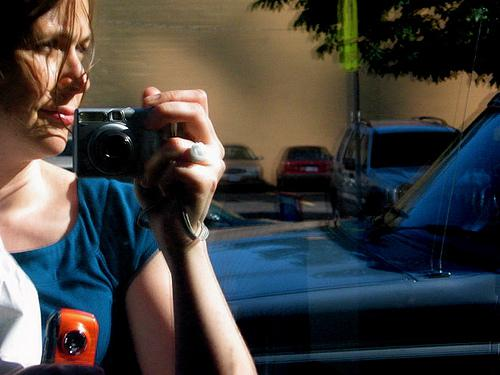Question: how is the woman standing?
Choices:
A. Still.
B. On one foot.
C. Leaning on the wall.
D. On tip toes.
Answer with the letter. Answer: A Question: why is she holding the camera?
Choices:
A. To take a picture.
B. To load it.
C. To fix it.
D. To unwrap it.
Answer with the letter. Answer: A Question: what is she doing?
Choices:
A. Walking.
B. Sitting on a bench.
C. On phone.
D. Taking a picture.
Answer with the letter. Answer: D Question: where is this taken?
Choices:
A. In a park.
B. At the beach.
C. Outside a building.
D. At the airport.
Answer with the letter. Answer: C Question: what color shirt is she wearing?
Choices:
A. Green.
B. Yellow.
C. Blue.
D. White.
Answer with the letter. Answer: C Question: when did this happen?
Choices:
A. During the day.
B. At night.
C. At Dusk.
D. At breakfast.
Answer with the letter. Answer: A 